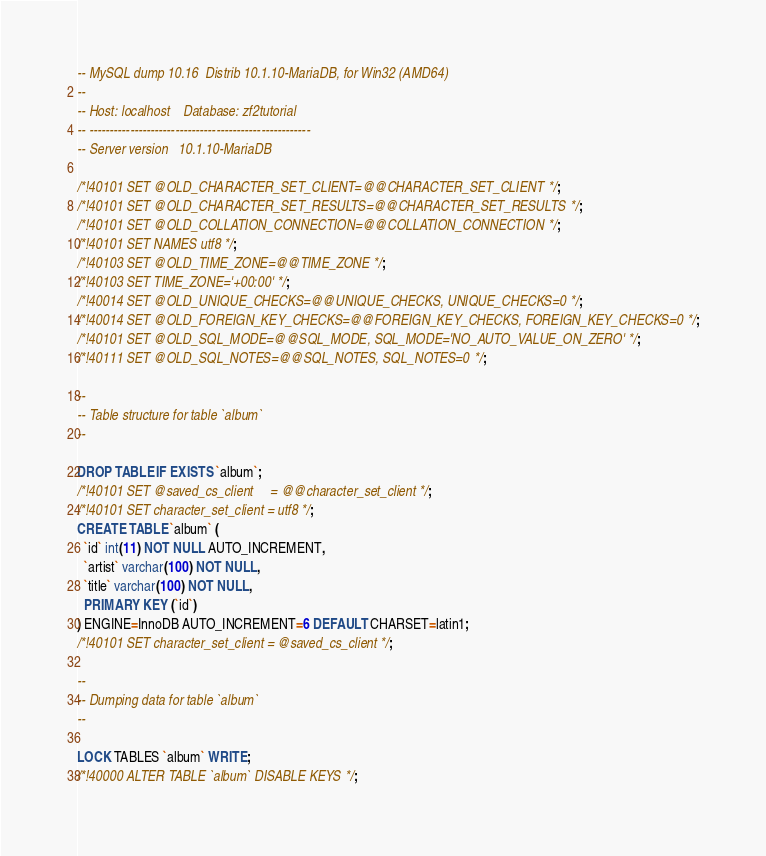<code> <loc_0><loc_0><loc_500><loc_500><_SQL_>-- MySQL dump 10.16  Distrib 10.1.10-MariaDB, for Win32 (AMD64)
--
-- Host: localhost    Database: zf2tutorial
-- ------------------------------------------------------
-- Server version	10.1.10-MariaDB

/*!40101 SET @OLD_CHARACTER_SET_CLIENT=@@CHARACTER_SET_CLIENT */;
/*!40101 SET @OLD_CHARACTER_SET_RESULTS=@@CHARACTER_SET_RESULTS */;
/*!40101 SET @OLD_COLLATION_CONNECTION=@@COLLATION_CONNECTION */;
/*!40101 SET NAMES utf8 */;
/*!40103 SET @OLD_TIME_ZONE=@@TIME_ZONE */;
/*!40103 SET TIME_ZONE='+00:00' */;
/*!40014 SET @OLD_UNIQUE_CHECKS=@@UNIQUE_CHECKS, UNIQUE_CHECKS=0 */;
/*!40014 SET @OLD_FOREIGN_KEY_CHECKS=@@FOREIGN_KEY_CHECKS, FOREIGN_KEY_CHECKS=0 */;
/*!40101 SET @OLD_SQL_MODE=@@SQL_MODE, SQL_MODE='NO_AUTO_VALUE_ON_ZERO' */;
/*!40111 SET @OLD_SQL_NOTES=@@SQL_NOTES, SQL_NOTES=0 */;

--
-- Table structure for table `album`
--

DROP TABLE IF EXISTS `album`;
/*!40101 SET @saved_cs_client     = @@character_set_client */;
/*!40101 SET character_set_client = utf8 */;
CREATE TABLE `album` (
  `id` int(11) NOT NULL AUTO_INCREMENT,
  `artist` varchar(100) NOT NULL,
  `title` varchar(100) NOT NULL,
  PRIMARY KEY (`id`)
) ENGINE=InnoDB AUTO_INCREMENT=6 DEFAULT CHARSET=latin1;
/*!40101 SET character_set_client = @saved_cs_client */;

--
-- Dumping data for table `album`
--

LOCK TABLES `album` WRITE;
/*!40000 ALTER TABLE `album` DISABLE KEYS */;</code> 